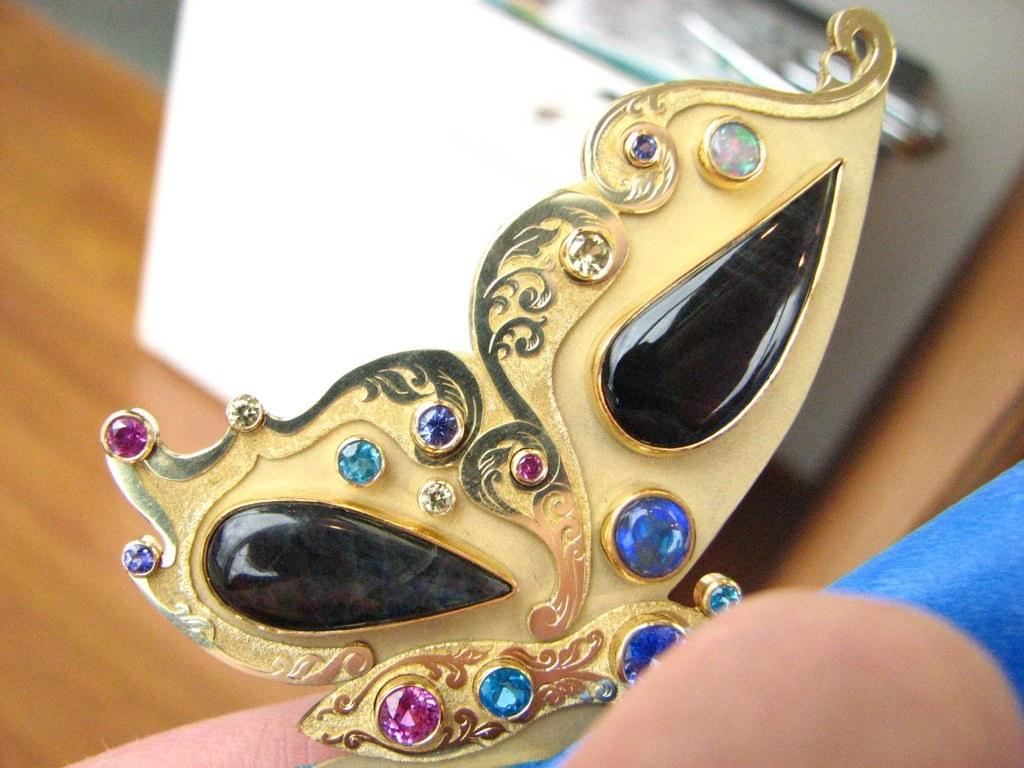What is the main object in the image? There is a golden color face mask in the image. What color is the object on the right side of the image? The object on the right side of the image is blue. How would you describe the overall clarity of the image? The image is slightly blurry in the background. What type of cheese is being farmed by the error in the image? There is no cheese or farmer present in the image, and no error is mentioned in the provided facts. 